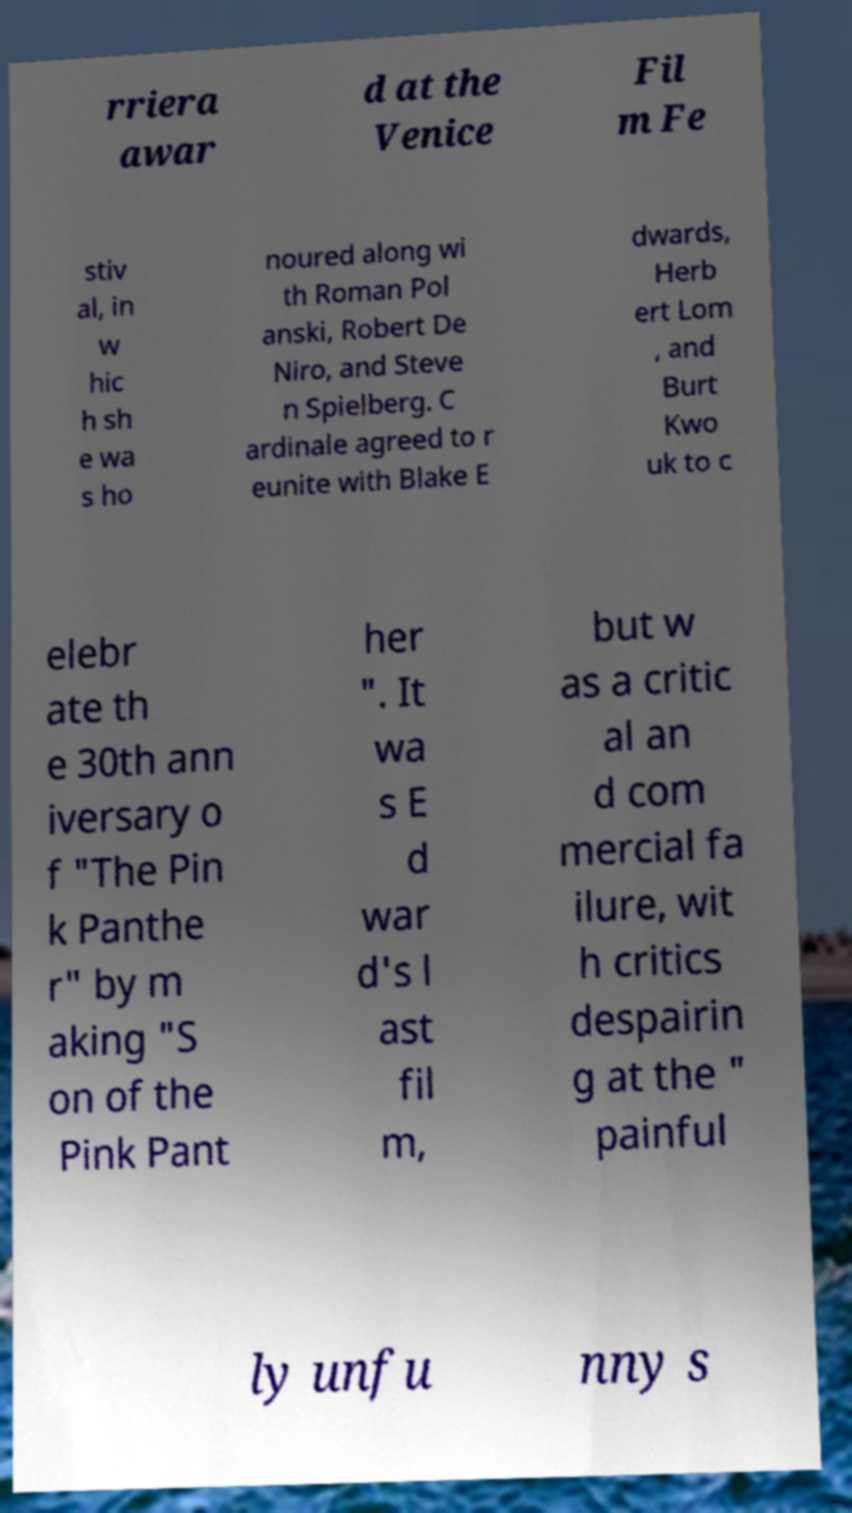There's text embedded in this image that I need extracted. Can you transcribe it verbatim? rriera awar d at the Venice Fil m Fe stiv al, in w hic h sh e wa s ho noured along wi th Roman Pol anski, Robert De Niro, and Steve n Spielberg. C ardinale agreed to r eunite with Blake E dwards, Herb ert Lom , and Burt Kwo uk to c elebr ate th e 30th ann iversary o f "The Pin k Panthe r" by m aking "S on of the Pink Pant her ". It wa s E d war d's l ast fil m, but w as a critic al an d com mercial fa ilure, wit h critics despairin g at the " painful ly unfu nny s 